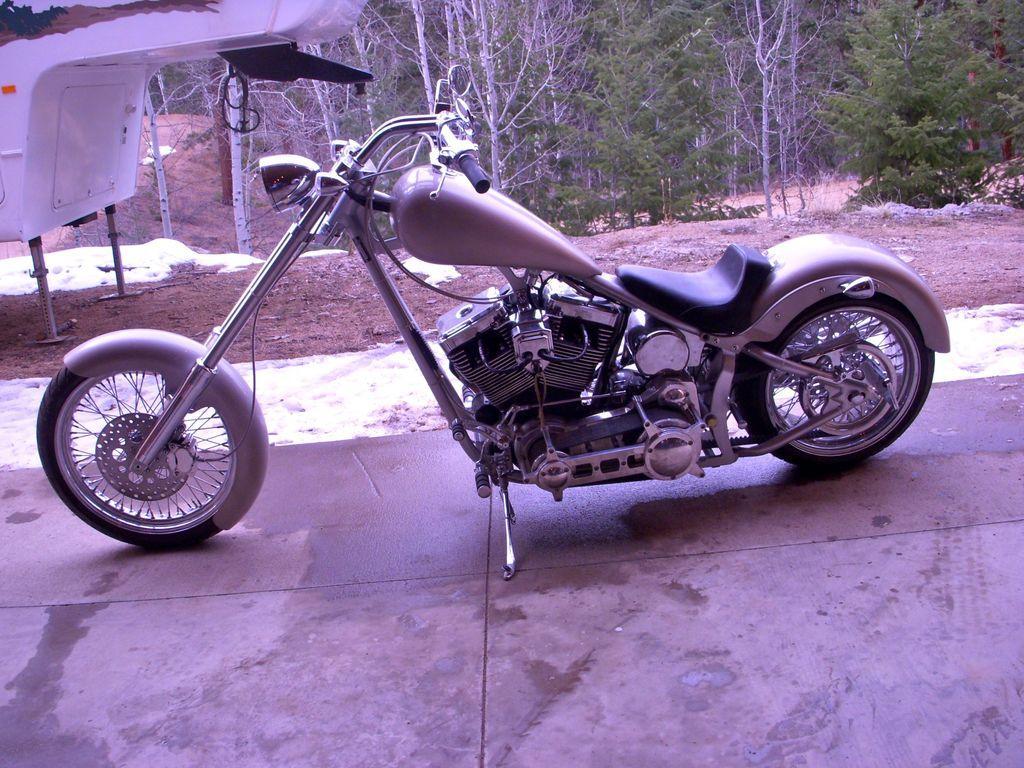In one or two sentences, can you explain what this image depicts? In this picture we can see a motor bike and an object on the ground and in the background we can see trees. 